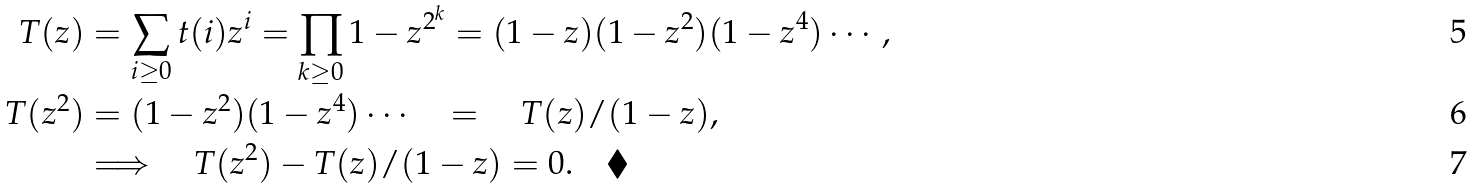<formula> <loc_0><loc_0><loc_500><loc_500>T ( z ) & = \sum _ { i \geq 0 } t ( i ) z ^ { i } = \prod _ { k \geq 0 } 1 - z ^ { 2 ^ { k } } = ( 1 - z ) ( 1 - z ^ { 2 } ) ( 1 - z ^ { 4 } ) \cdots , \\ T ( z ^ { 2 } ) & = ( 1 - z ^ { 2 } ) ( 1 - z ^ { 4 } ) \cdots \quad = \quad T ( z ) / ( 1 - z ) , \\ & \Longrightarrow \quad T ( z ^ { 2 } ) - T ( z ) / ( 1 - z ) = 0 . \quad \blacklozenge</formula> 